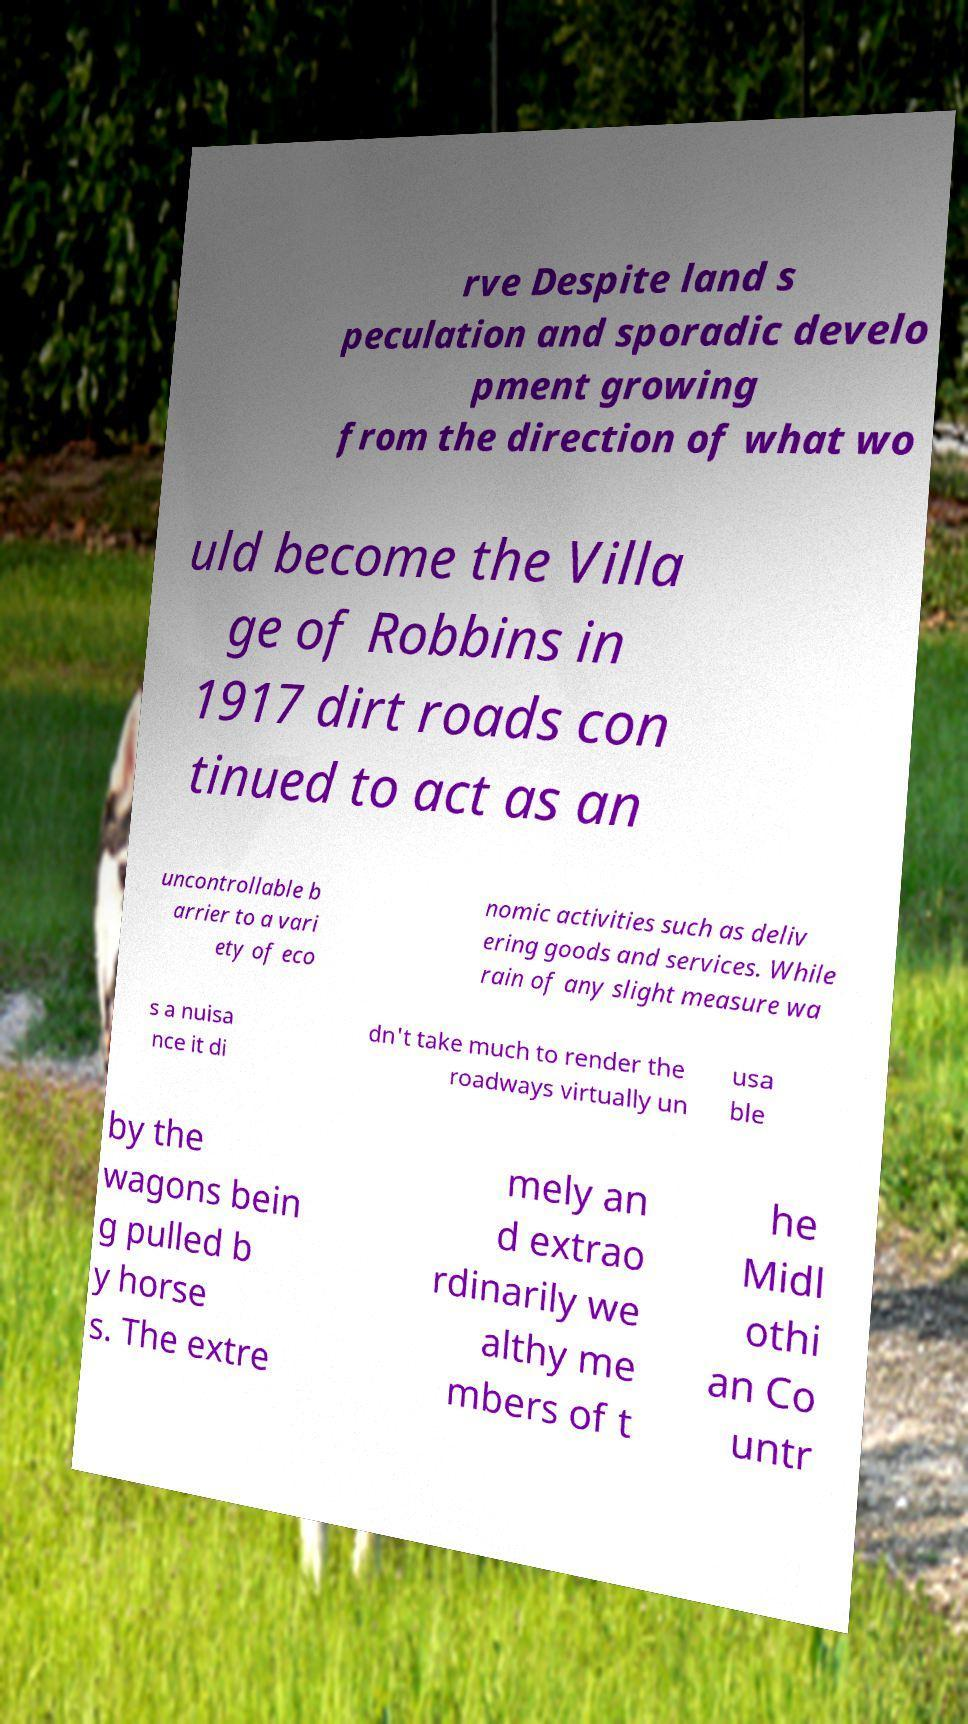What messages or text are displayed in this image? I need them in a readable, typed format. rve Despite land s peculation and sporadic develo pment growing from the direction of what wo uld become the Villa ge of Robbins in 1917 dirt roads con tinued to act as an uncontrollable b arrier to a vari ety of eco nomic activities such as deliv ering goods and services. While rain of any slight measure wa s a nuisa nce it di dn't take much to render the roadways virtually un usa ble by the wagons bein g pulled b y horse s. The extre mely an d extrao rdinarily we althy me mbers of t he Midl othi an Co untr 